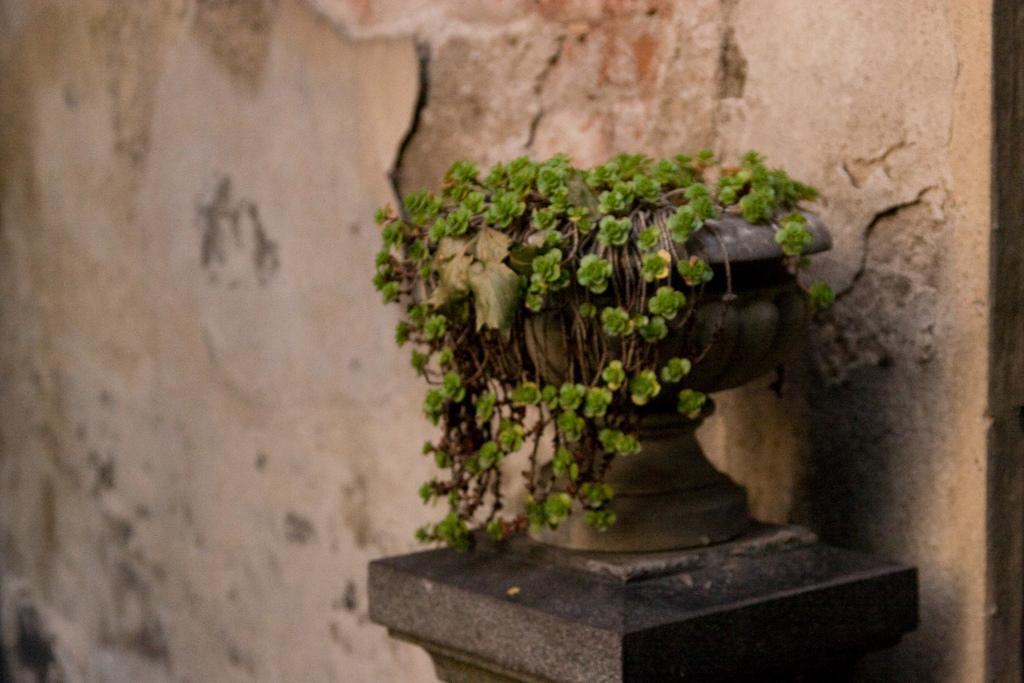Describe this image in one or two sentences. In this image there is a pot in which there are plants. In the background there is a wall. 